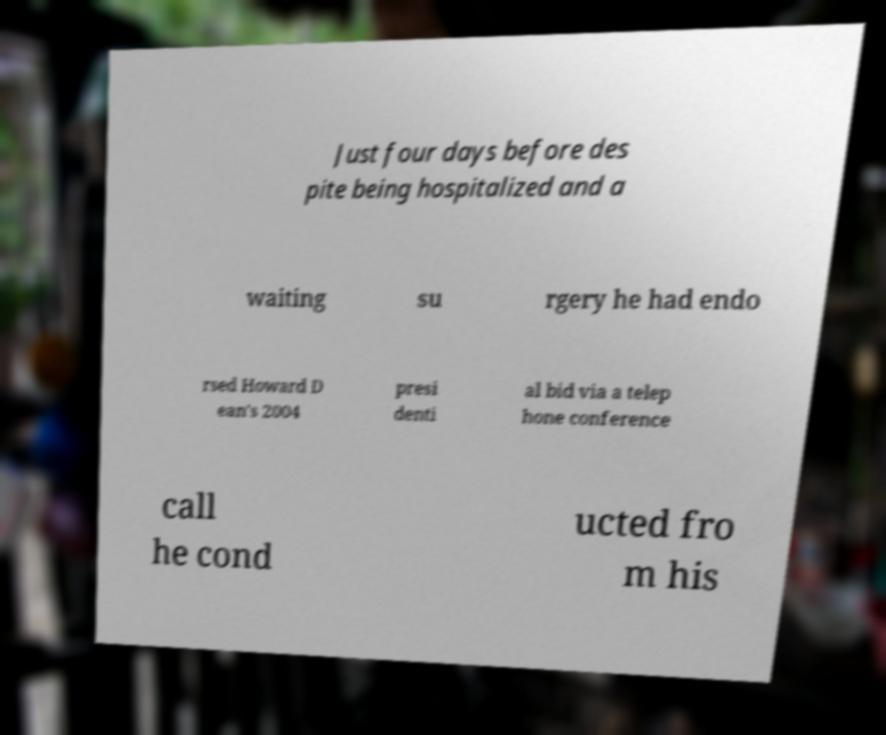I need the written content from this picture converted into text. Can you do that? Just four days before des pite being hospitalized and a waiting su rgery he had endo rsed Howard D ean's 2004 presi denti al bid via a telep hone conference call he cond ucted fro m his 